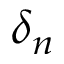Convert formula to latex. <formula><loc_0><loc_0><loc_500><loc_500>\delta _ { n }</formula> 